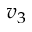Convert formula to latex. <formula><loc_0><loc_0><loc_500><loc_500>v _ { 3 }</formula> 